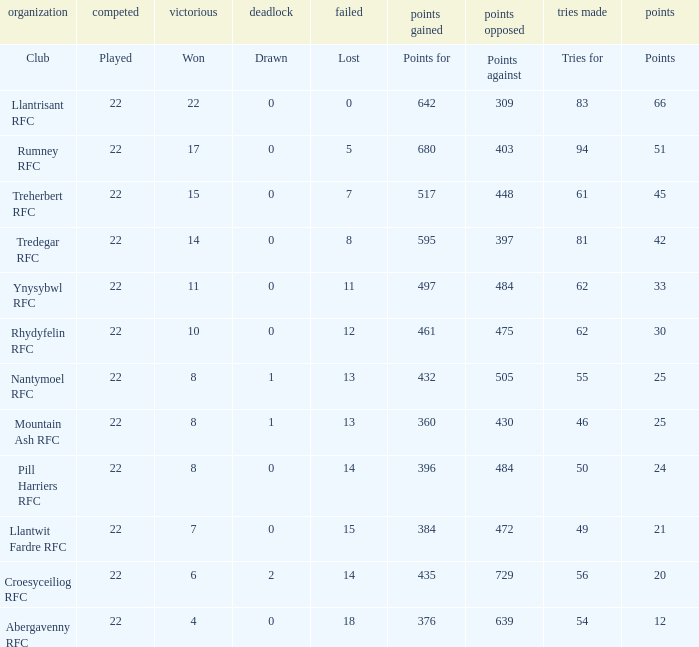How many points for were scored by the team that won exactly 22? 642.0. 